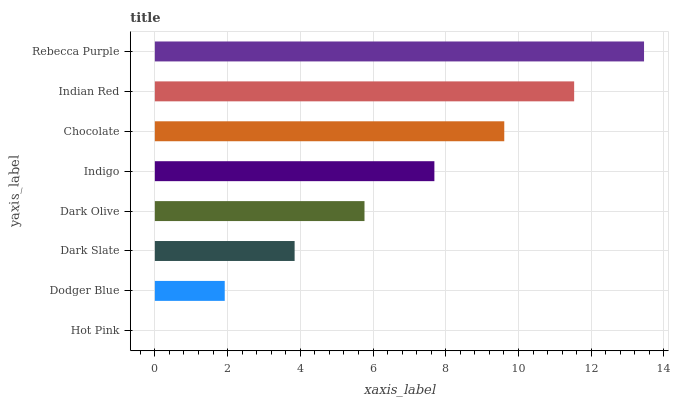Is Hot Pink the minimum?
Answer yes or no. Yes. Is Rebecca Purple the maximum?
Answer yes or no. Yes. Is Dodger Blue the minimum?
Answer yes or no. No. Is Dodger Blue the maximum?
Answer yes or no. No. Is Dodger Blue greater than Hot Pink?
Answer yes or no. Yes. Is Hot Pink less than Dodger Blue?
Answer yes or no. Yes. Is Hot Pink greater than Dodger Blue?
Answer yes or no. No. Is Dodger Blue less than Hot Pink?
Answer yes or no. No. Is Indigo the high median?
Answer yes or no. Yes. Is Dark Olive the low median?
Answer yes or no. Yes. Is Dodger Blue the high median?
Answer yes or no. No. Is Dark Slate the low median?
Answer yes or no. No. 